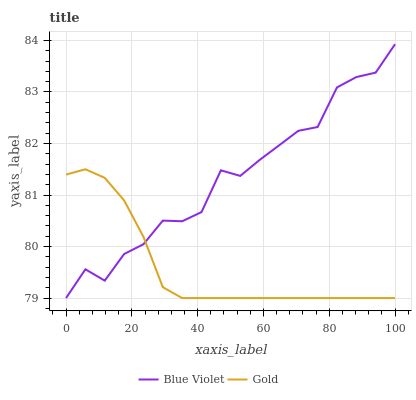Does Blue Violet have the minimum area under the curve?
Answer yes or no. No. Is Blue Violet the smoothest?
Answer yes or no. No. 